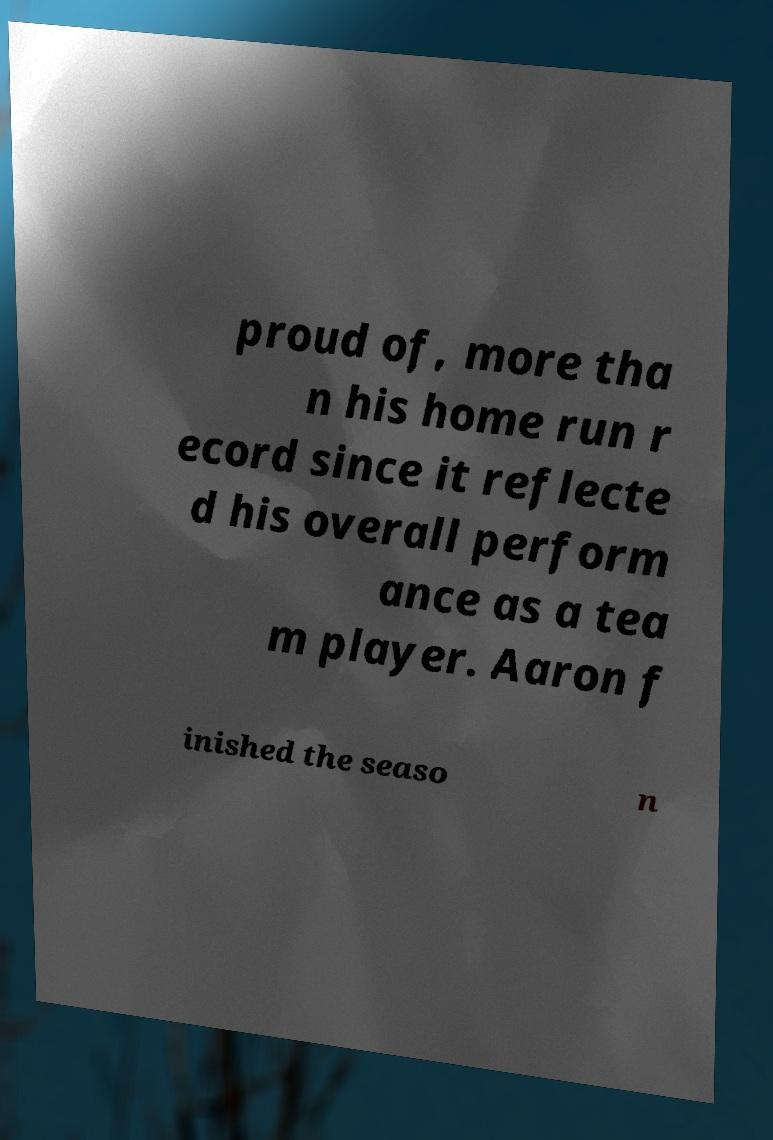Could you assist in decoding the text presented in this image and type it out clearly? proud of, more tha n his home run r ecord since it reflecte d his overall perform ance as a tea m player. Aaron f inished the seaso n 